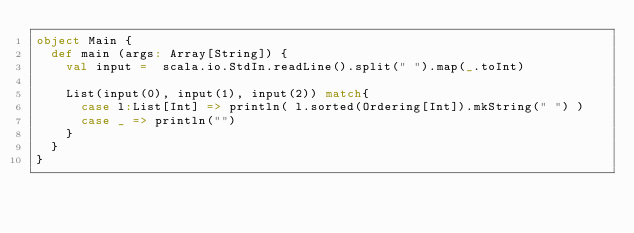Convert code to text. <code><loc_0><loc_0><loc_500><loc_500><_Scala_>object Main {
  def main (args: Array[String]) {
    val input =  scala.io.StdIn.readLine().split(" ").map(_.toInt)
   
    List(input(0), input(1), input(2)) match{
      case l:List[Int] => println( l.sorted(Ordering[Int]).mkString(" ") )
      case _ => println("")
    }
  }
}</code> 